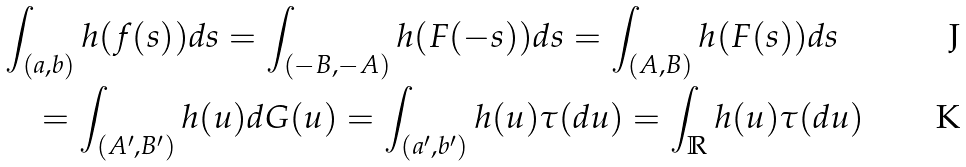Convert formula to latex. <formula><loc_0><loc_0><loc_500><loc_500>& \int _ { ( a , b ) } h ( f ( s ) ) d s = \int _ { ( - B , - A ) } h ( F ( - s ) ) d s = \int _ { ( A , B ) } h ( F ( s ) ) d s \\ & \quad = \int _ { ( A ^ { \prime } , B ^ { \prime } ) } h ( u ) d G ( u ) = \int _ { ( a ^ { \prime } , b ^ { \prime } ) } h ( u ) \tau ( d u ) = \int _ { \mathbb { R } } h ( u ) \tau ( d u )</formula> 